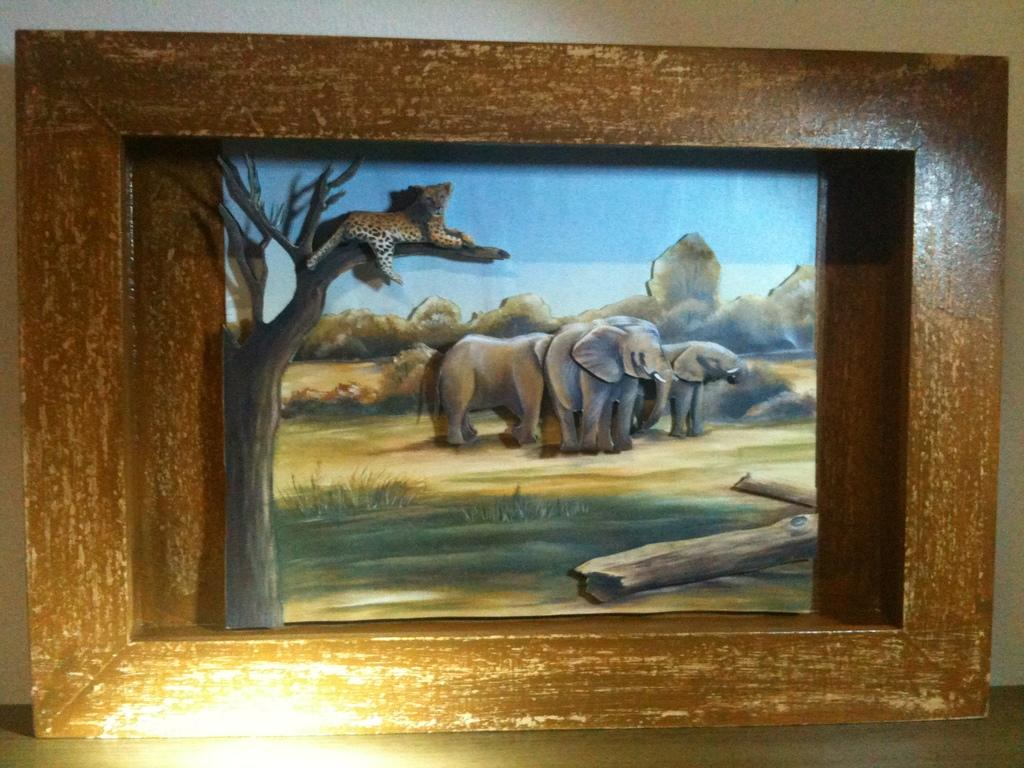What is present in the image that has a structure or outline? There is a frame in the image. What can be seen inside the frame? There are animals visible inside the frame. What type of material is used to create the wooden barks in the image? The wooden barks in the image are made of wood. What type of lead is used to create the animals inside the frame? There is no mention of lead being used in the image; the animals are visible inside the frame. Can you tell me how many basins are present in the image? There is no mention of basins in the image; the main subjects are the frame, animals, and wooden barks. 